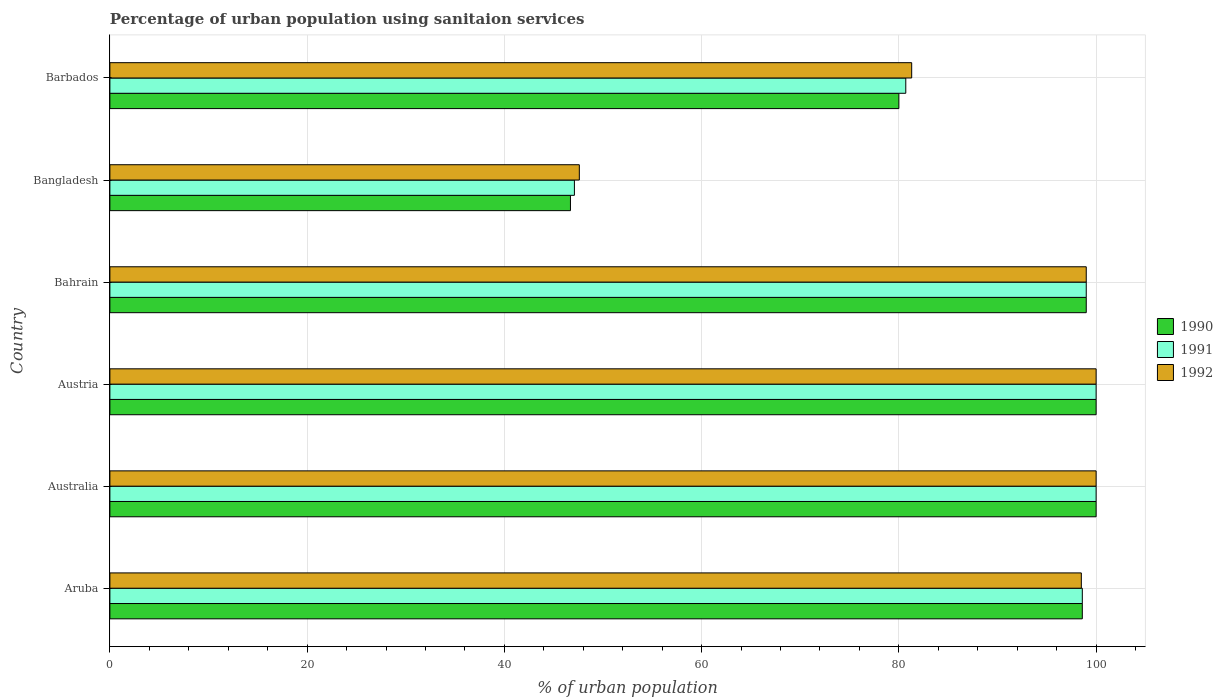How many different coloured bars are there?
Keep it short and to the point. 3. Are the number of bars per tick equal to the number of legend labels?
Make the answer very short. Yes. Are the number of bars on each tick of the Y-axis equal?
Provide a succinct answer. Yes. How many bars are there on the 2nd tick from the top?
Make the answer very short. 3. What is the label of the 4th group of bars from the top?
Provide a succinct answer. Austria. Across all countries, what is the minimum percentage of urban population using sanitaion services in 1991?
Keep it short and to the point. 47.1. What is the total percentage of urban population using sanitaion services in 1990 in the graph?
Make the answer very short. 524.3. What is the difference between the percentage of urban population using sanitaion services in 1990 in Australia and that in Bahrain?
Keep it short and to the point. 1. What is the average percentage of urban population using sanitaion services in 1991 per country?
Your response must be concise. 87.57. What is the difference between the percentage of urban population using sanitaion services in 1991 and percentage of urban population using sanitaion services in 1990 in Bangladesh?
Offer a terse response. 0.4. What is the ratio of the percentage of urban population using sanitaion services in 1990 in Aruba to that in Bahrain?
Provide a succinct answer. 1. Is the percentage of urban population using sanitaion services in 1991 in Aruba less than that in Australia?
Offer a terse response. Yes. What is the difference between the highest and the second highest percentage of urban population using sanitaion services in 1992?
Your answer should be compact. 0. What is the difference between the highest and the lowest percentage of urban population using sanitaion services in 1992?
Your answer should be compact. 52.4. Is it the case that in every country, the sum of the percentage of urban population using sanitaion services in 1992 and percentage of urban population using sanitaion services in 1991 is greater than the percentage of urban population using sanitaion services in 1990?
Provide a succinct answer. Yes. Are all the bars in the graph horizontal?
Provide a succinct answer. Yes. How many countries are there in the graph?
Your answer should be very brief. 6. What is the difference between two consecutive major ticks on the X-axis?
Provide a succinct answer. 20. Are the values on the major ticks of X-axis written in scientific E-notation?
Offer a terse response. No. Does the graph contain any zero values?
Offer a very short reply. No. Does the graph contain grids?
Make the answer very short. Yes. How are the legend labels stacked?
Your answer should be compact. Vertical. What is the title of the graph?
Your response must be concise. Percentage of urban population using sanitaion services. What is the label or title of the X-axis?
Give a very brief answer. % of urban population. What is the % of urban population of 1990 in Aruba?
Keep it short and to the point. 98.6. What is the % of urban population of 1991 in Aruba?
Offer a very short reply. 98.6. What is the % of urban population in 1992 in Aruba?
Your answer should be compact. 98.5. What is the % of urban population of 1990 in Australia?
Offer a very short reply. 100. What is the % of urban population in 1991 in Australia?
Offer a terse response. 100. What is the % of urban population in 1992 in Australia?
Your answer should be very brief. 100. What is the % of urban population of 1991 in Austria?
Your response must be concise. 100. What is the % of urban population of 1992 in Austria?
Give a very brief answer. 100. What is the % of urban population in 1990 in Bangladesh?
Ensure brevity in your answer.  46.7. What is the % of urban population of 1991 in Bangladesh?
Ensure brevity in your answer.  47.1. What is the % of urban population of 1992 in Bangladesh?
Provide a succinct answer. 47.6. What is the % of urban population in 1990 in Barbados?
Make the answer very short. 80. What is the % of urban population of 1991 in Barbados?
Provide a succinct answer. 80.7. What is the % of urban population of 1992 in Barbados?
Keep it short and to the point. 81.3. Across all countries, what is the maximum % of urban population of 1991?
Give a very brief answer. 100. Across all countries, what is the maximum % of urban population of 1992?
Your answer should be very brief. 100. Across all countries, what is the minimum % of urban population in 1990?
Provide a succinct answer. 46.7. Across all countries, what is the minimum % of urban population in 1991?
Make the answer very short. 47.1. Across all countries, what is the minimum % of urban population of 1992?
Offer a very short reply. 47.6. What is the total % of urban population of 1990 in the graph?
Your answer should be compact. 524.3. What is the total % of urban population of 1991 in the graph?
Your response must be concise. 525.4. What is the total % of urban population of 1992 in the graph?
Offer a very short reply. 526.4. What is the difference between the % of urban population of 1991 in Aruba and that in Australia?
Provide a short and direct response. -1.4. What is the difference between the % of urban population of 1990 in Aruba and that in Austria?
Your answer should be very brief. -1.4. What is the difference between the % of urban population in 1992 in Aruba and that in Austria?
Your response must be concise. -1.5. What is the difference between the % of urban population in 1991 in Aruba and that in Bahrain?
Keep it short and to the point. -0.4. What is the difference between the % of urban population of 1992 in Aruba and that in Bahrain?
Keep it short and to the point. -0.5. What is the difference between the % of urban population of 1990 in Aruba and that in Bangladesh?
Ensure brevity in your answer.  51.9. What is the difference between the % of urban population in 1991 in Aruba and that in Bangladesh?
Offer a terse response. 51.5. What is the difference between the % of urban population in 1992 in Aruba and that in Bangladesh?
Your response must be concise. 50.9. What is the difference between the % of urban population of 1990 in Aruba and that in Barbados?
Your answer should be very brief. 18.6. What is the difference between the % of urban population of 1991 in Aruba and that in Barbados?
Your response must be concise. 17.9. What is the difference between the % of urban population in 1992 in Aruba and that in Barbados?
Give a very brief answer. 17.2. What is the difference between the % of urban population of 1991 in Australia and that in Austria?
Offer a very short reply. 0. What is the difference between the % of urban population in 1992 in Australia and that in Austria?
Your answer should be compact. 0. What is the difference between the % of urban population in 1991 in Australia and that in Bahrain?
Keep it short and to the point. 1. What is the difference between the % of urban population of 1992 in Australia and that in Bahrain?
Ensure brevity in your answer.  1. What is the difference between the % of urban population in 1990 in Australia and that in Bangladesh?
Your response must be concise. 53.3. What is the difference between the % of urban population in 1991 in Australia and that in Bangladesh?
Make the answer very short. 52.9. What is the difference between the % of urban population in 1992 in Australia and that in Bangladesh?
Make the answer very short. 52.4. What is the difference between the % of urban population in 1991 in Australia and that in Barbados?
Offer a terse response. 19.3. What is the difference between the % of urban population of 1992 in Australia and that in Barbados?
Provide a succinct answer. 18.7. What is the difference between the % of urban population in 1990 in Austria and that in Bahrain?
Your response must be concise. 1. What is the difference between the % of urban population of 1990 in Austria and that in Bangladesh?
Keep it short and to the point. 53.3. What is the difference between the % of urban population in 1991 in Austria and that in Bangladesh?
Offer a very short reply. 52.9. What is the difference between the % of urban population in 1992 in Austria and that in Bangladesh?
Ensure brevity in your answer.  52.4. What is the difference between the % of urban population in 1990 in Austria and that in Barbados?
Your answer should be very brief. 20. What is the difference between the % of urban population of 1991 in Austria and that in Barbados?
Give a very brief answer. 19.3. What is the difference between the % of urban population of 1992 in Austria and that in Barbados?
Ensure brevity in your answer.  18.7. What is the difference between the % of urban population in 1990 in Bahrain and that in Bangladesh?
Ensure brevity in your answer.  52.3. What is the difference between the % of urban population of 1991 in Bahrain and that in Bangladesh?
Give a very brief answer. 51.9. What is the difference between the % of urban population of 1992 in Bahrain and that in Bangladesh?
Your response must be concise. 51.4. What is the difference between the % of urban population in 1990 in Bahrain and that in Barbados?
Provide a succinct answer. 19. What is the difference between the % of urban population in 1991 in Bahrain and that in Barbados?
Provide a short and direct response. 18.3. What is the difference between the % of urban population in 1992 in Bahrain and that in Barbados?
Provide a short and direct response. 17.7. What is the difference between the % of urban population of 1990 in Bangladesh and that in Barbados?
Keep it short and to the point. -33.3. What is the difference between the % of urban population in 1991 in Bangladesh and that in Barbados?
Your answer should be very brief. -33.6. What is the difference between the % of urban population in 1992 in Bangladesh and that in Barbados?
Give a very brief answer. -33.7. What is the difference between the % of urban population in 1990 in Aruba and the % of urban population in 1991 in Australia?
Provide a succinct answer. -1.4. What is the difference between the % of urban population of 1990 in Aruba and the % of urban population of 1991 in Austria?
Your answer should be compact. -1.4. What is the difference between the % of urban population of 1990 in Aruba and the % of urban population of 1992 in Austria?
Your answer should be compact. -1.4. What is the difference between the % of urban population in 1991 in Aruba and the % of urban population in 1992 in Austria?
Your response must be concise. -1.4. What is the difference between the % of urban population in 1990 in Aruba and the % of urban population in 1992 in Bahrain?
Offer a very short reply. -0.4. What is the difference between the % of urban population in 1990 in Aruba and the % of urban population in 1991 in Bangladesh?
Offer a very short reply. 51.5. What is the difference between the % of urban population of 1990 in Aruba and the % of urban population of 1992 in Bangladesh?
Make the answer very short. 51. What is the difference between the % of urban population in 1991 in Aruba and the % of urban population in 1992 in Bangladesh?
Provide a short and direct response. 51. What is the difference between the % of urban population of 1990 in Aruba and the % of urban population of 1991 in Barbados?
Provide a short and direct response. 17.9. What is the difference between the % of urban population in 1991 in Australia and the % of urban population in 1992 in Austria?
Provide a succinct answer. 0. What is the difference between the % of urban population in 1990 in Australia and the % of urban population in 1991 in Bangladesh?
Your response must be concise. 52.9. What is the difference between the % of urban population of 1990 in Australia and the % of urban population of 1992 in Bangladesh?
Your answer should be very brief. 52.4. What is the difference between the % of urban population of 1991 in Australia and the % of urban population of 1992 in Bangladesh?
Your answer should be very brief. 52.4. What is the difference between the % of urban population in 1990 in Australia and the % of urban population in 1991 in Barbados?
Your answer should be compact. 19.3. What is the difference between the % of urban population of 1991 in Australia and the % of urban population of 1992 in Barbados?
Offer a terse response. 18.7. What is the difference between the % of urban population in 1990 in Austria and the % of urban population in 1991 in Bahrain?
Your response must be concise. 1. What is the difference between the % of urban population of 1990 in Austria and the % of urban population of 1991 in Bangladesh?
Provide a succinct answer. 52.9. What is the difference between the % of urban population in 1990 in Austria and the % of urban population in 1992 in Bangladesh?
Provide a short and direct response. 52.4. What is the difference between the % of urban population of 1991 in Austria and the % of urban population of 1992 in Bangladesh?
Provide a succinct answer. 52.4. What is the difference between the % of urban population in 1990 in Austria and the % of urban population in 1991 in Barbados?
Make the answer very short. 19.3. What is the difference between the % of urban population in 1990 in Austria and the % of urban population in 1992 in Barbados?
Your response must be concise. 18.7. What is the difference between the % of urban population of 1990 in Bahrain and the % of urban population of 1991 in Bangladesh?
Keep it short and to the point. 51.9. What is the difference between the % of urban population of 1990 in Bahrain and the % of urban population of 1992 in Bangladesh?
Provide a short and direct response. 51.4. What is the difference between the % of urban population of 1991 in Bahrain and the % of urban population of 1992 in Bangladesh?
Make the answer very short. 51.4. What is the difference between the % of urban population of 1990 in Bangladesh and the % of urban population of 1991 in Barbados?
Ensure brevity in your answer.  -34. What is the difference between the % of urban population in 1990 in Bangladesh and the % of urban population in 1992 in Barbados?
Offer a terse response. -34.6. What is the difference between the % of urban population of 1991 in Bangladesh and the % of urban population of 1992 in Barbados?
Offer a very short reply. -34.2. What is the average % of urban population in 1990 per country?
Make the answer very short. 87.38. What is the average % of urban population in 1991 per country?
Offer a terse response. 87.57. What is the average % of urban population of 1992 per country?
Your answer should be very brief. 87.73. What is the difference between the % of urban population of 1990 and % of urban population of 1992 in Australia?
Your answer should be compact. 0. What is the difference between the % of urban population in 1991 and % of urban population in 1992 in Australia?
Give a very brief answer. 0. What is the difference between the % of urban population in 1990 and % of urban population in 1991 in Bahrain?
Your response must be concise. 0. What is the difference between the % of urban population of 1990 and % of urban population of 1991 in Bangladesh?
Provide a succinct answer. -0.4. What is the difference between the % of urban population in 1990 and % of urban population in 1992 in Bangladesh?
Your response must be concise. -0.9. What is the difference between the % of urban population in 1990 and % of urban population in 1991 in Barbados?
Ensure brevity in your answer.  -0.7. What is the ratio of the % of urban population of 1990 in Aruba to that in Australia?
Give a very brief answer. 0.99. What is the ratio of the % of urban population in 1991 in Aruba to that in Australia?
Provide a succinct answer. 0.99. What is the ratio of the % of urban population of 1991 in Aruba to that in Austria?
Provide a short and direct response. 0.99. What is the ratio of the % of urban population in 1992 in Aruba to that in Austria?
Offer a very short reply. 0.98. What is the ratio of the % of urban population of 1990 in Aruba to that in Bahrain?
Ensure brevity in your answer.  1. What is the ratio of the % of urban population of 1992 in Aruba to that in Bahrain?
Your answer should be very brief. 0.99. What is the ratio of the % of urban population of 1990 in Aruba to that in Bangladesh?
Make the answer very short. 2.11. What is the ratio of the % of urban population in 1991 in Aruba to that in Bangladesh?
Provide a succinct answer. 2.09. What is the ratio of the % of urban population of 1992 in Aruba to that in Bangladesh?
Give a very brief answer. 2.07. What is the ratio of the % of urban population in 1990 in Aruba to that in Barbados?
Offer a very short reply. 1.23. What is the ratio of the % of urban population in 1991 in Aruba to that in Barbados?
Offer a very short reply. 1.22. What is the ratio of the % of urban population in 1992 in Aruba to that in Barbados?
Provide a short and direct response. 1.21. What is the ratio of the % of urban population of 1990 in Australia to that in Austria?
Ensure brevity in your answer.  1. What is the ratio of the % of urban population of 1991 in Australia to that in Austria?
Make the answer very short. 1. What is the ratio of the % of urban population in 1991 in Australia to that in Bahrain?
Give a very brief answer. 1.01. What is the ratio of the % of urban population of 1990 in Australia to that in Bangladesh?
Ensure brevity in your answer.  2.14. What is the ratio of the % of urban population of 1991 in Australia to that in Bangladesh?
Ensure brevity in your answer.  2.12. What is the ratio of the % of urban population of 1992 in Australia to that in Bangladesh?
Your answer should be very brief. 2.1. What is the ratio of the % of urban population in 1990 in Australia to that in Barbados?
Provide a succinct answer. 1.25. What is the ratio of the % of urban population of 1991 in Australia to that in Barbados?
Provide a succinct answer. 1.24. What is the ratio of the % of urban population in 1992 in Australia to that in Barbados?
Give a very brief answer. 1.23. What is the ratio of the % of urban population in 1991 in Austria to that in Bahrain?
Make the answer very short. 1.01. What is the ratio of the % of urban population of 1990 in Austria to that in Bangladesh?
Provide a succinct answer. 2.14. What is the ratio of the % of urban population in 1991 in Austria to that in Bangladesh?
Keep it short and to the point. 2.12. What is the ratio of the % of urban population in 1992 in Austria to that in Bangladesh?
Your response must be concise. 2.1. What is the ratio of the % of urban population of 1991 in Austria to that in Barbados?
Provide a succinct answer. 1.24. What is the ratio of the % of urban population in 1992 in Austria to that in Barbados?
Your answer should be very brief. 1.23. What is the ratio of the % of urban population in 1990 in Bahrain to that in Bangladesh?
Ensure brevity in your answer.  2.12. What is the ratio of the % of urban population of 1991 in Bahrain to that in Bangladesh?
Keep it short and to the point. 2.1. What is the ratio of the % of urban population of 1992 in Bahrain to that in Bangladesh?
Offer a very short reply. 2.08. What is the ratio of the % of urban population in 1990 in Bahrain to that in Barbados?
Your answer should be very brief. 1.24. What is the ratio of the % of urban population in 1991 in Bahrain to that in Barbados?
Provide a succinct answer. 1.23. What is the ratio of the % of urban population of 1992 in Bahrain to that in Barbados?
Make the answer very short. 1.22. What is the ratio of the % of urban population in 1990 in Bangladesh to that in Barbados?
Offer a terse response. 0.58. What is the ratio of the % of urban population in 1991 in Bangladesh to that in Barbados?
Provide a succinct answer. 0.58. What is the ratio of the % of urban population of 1992 in Bangladesh to that in Barbados?
Keep it short and to the point. 0.59. What is the difference between the highest and the lowest % of urban population in 1990?
Make the answer very short. 53.3. What is the difference between the highest and the lowest % of urban population of 1991?
Provide a short and direct response. 52.9. What is the difference between the highest and the lowest % of urban population of 1992?
Your answer should be very brief. 52.4. 